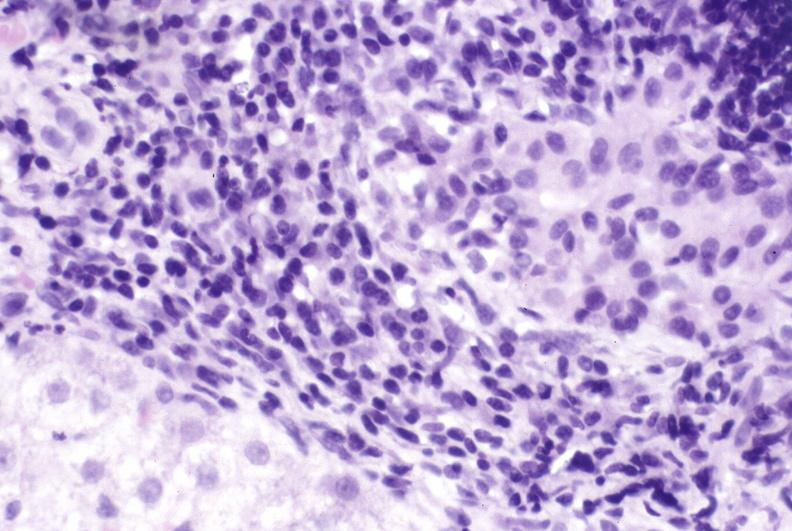what is present?
Answer the question using a single word or phrase. Hepatobiliary 